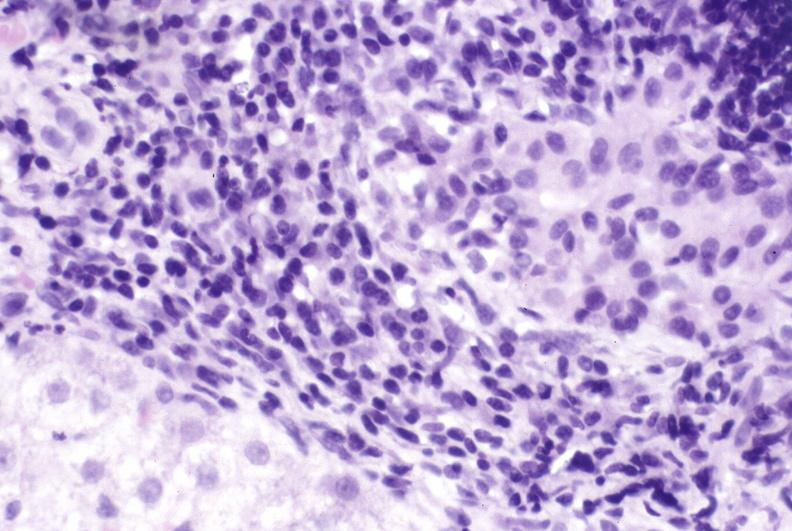what is present?
Answer the question using a single word or phrase. Hepatobiliary 